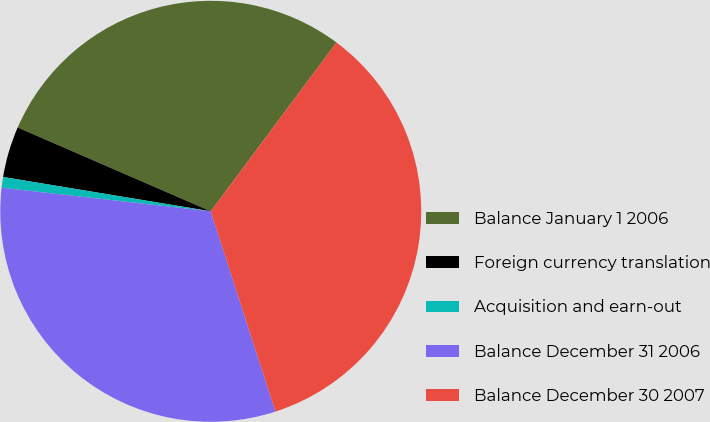<chart> <loc_0><loc_0><loc_500><loc_500><pie_chart><fcel>Balance January 1 2006<fcel>Foreign currency translation<fcel>Acquisition and earn-out<fcel>Balance December 31 2006<fcel>Balance December 30 2007<nl><fcel>28.67%<fcel>3.91%<fcel>0.82%<fcel>31.76%<fcel>34.85%<nl></chart> 